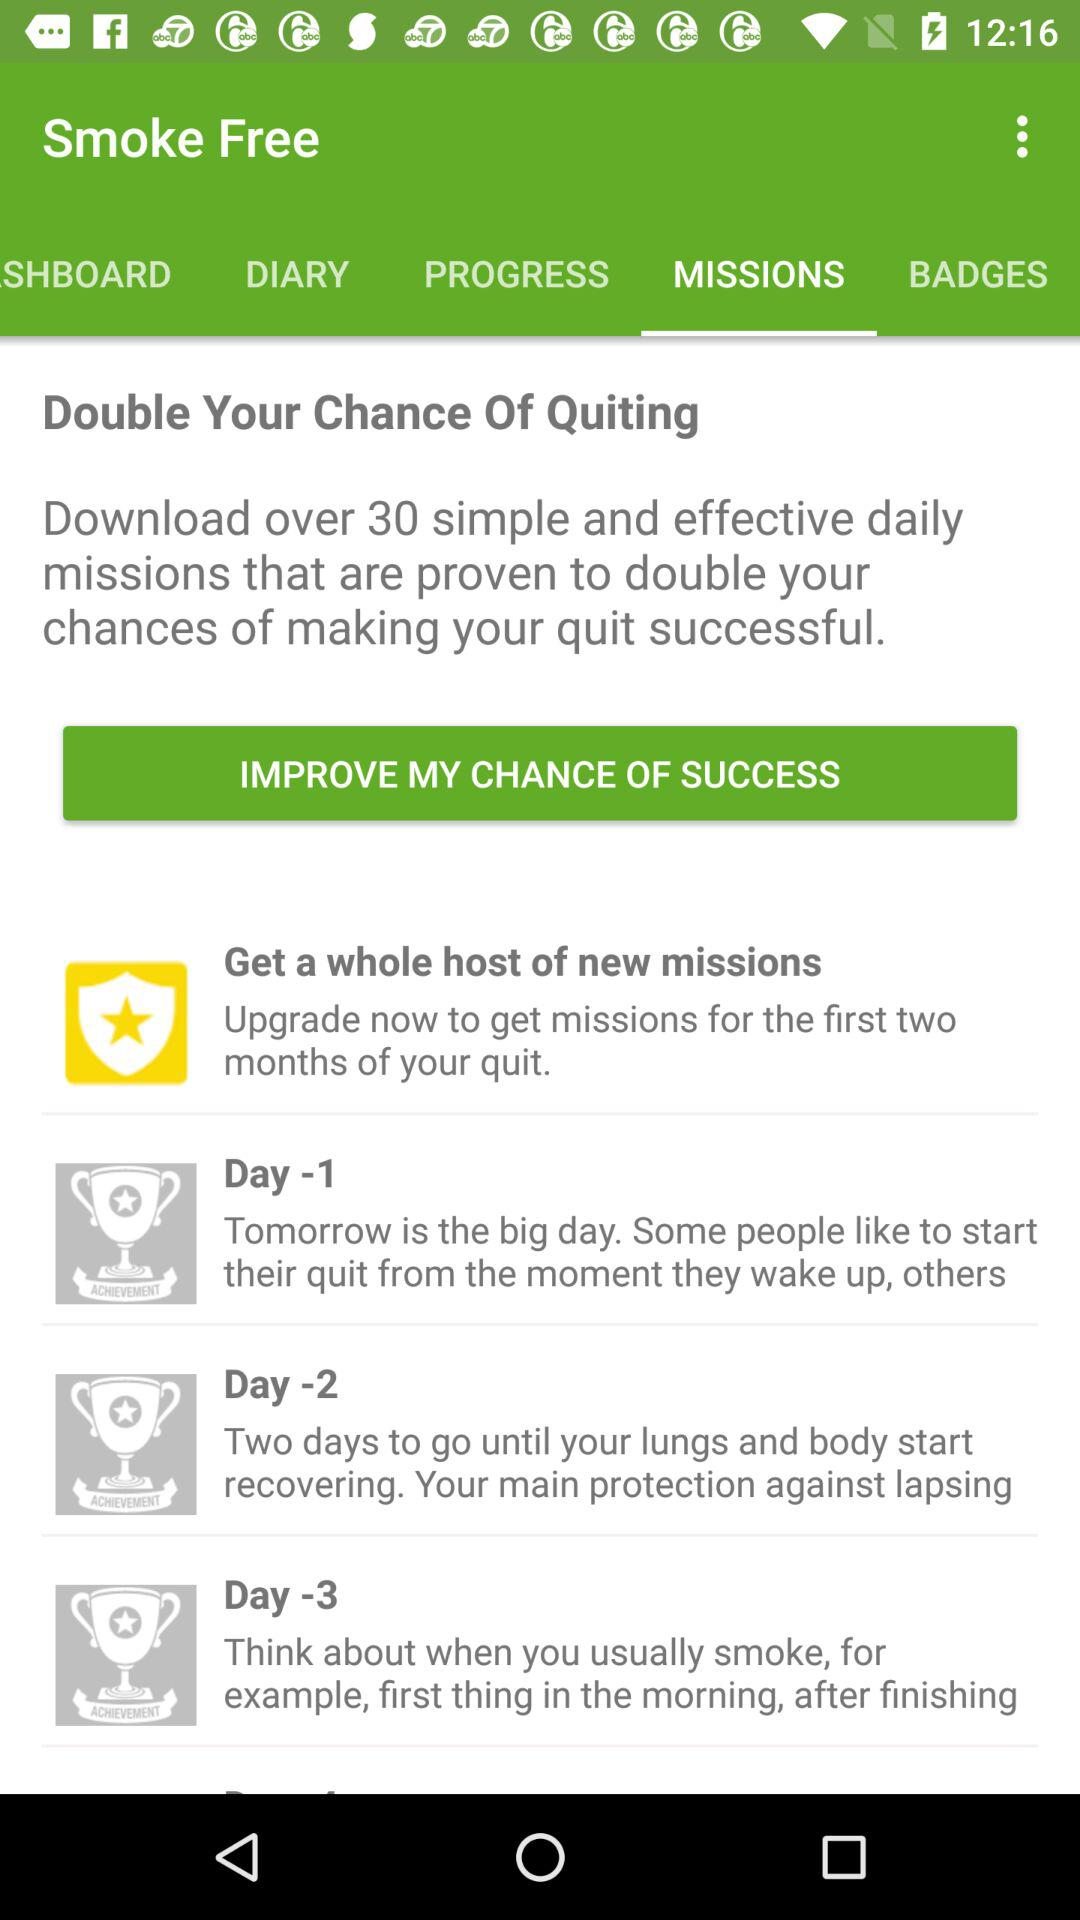What is the selected tab? The selected tab is "MISSIONS". 